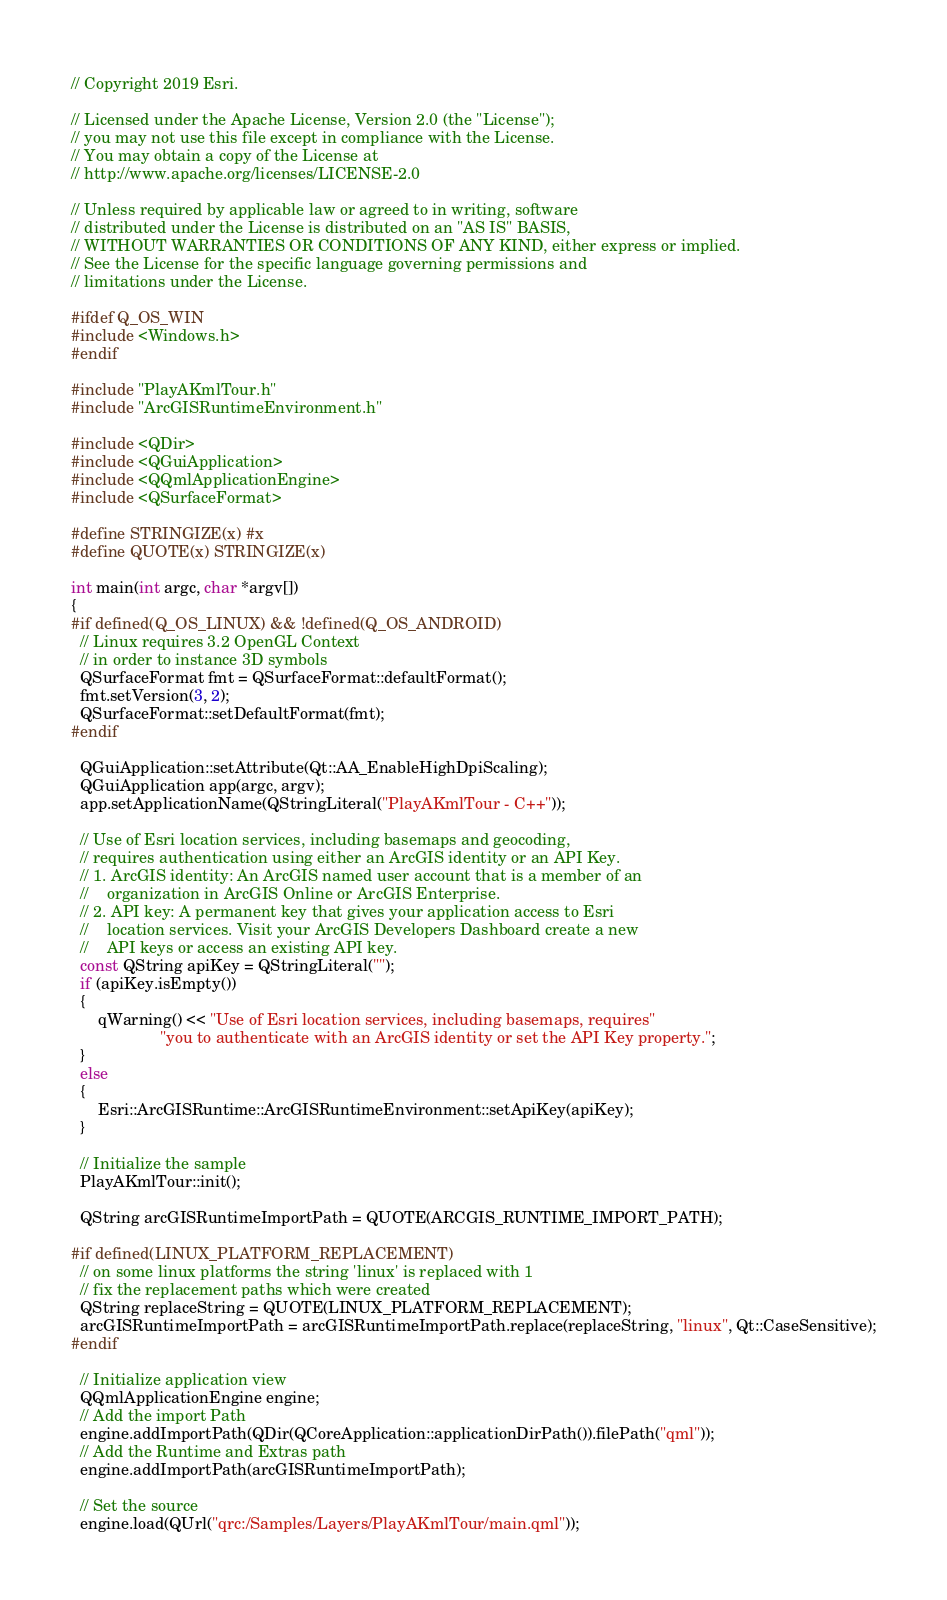Convert code to text. <code><loc_0><loc_0><loc_500><loc_500><_C++_>// Copyright 2019 Esri.

// Licensed under the Apache License, Version 2.0 (the "License");
// you may not use this file except in compliance with the License.
// You may obtain a copy of the License at
// http://www.apache.org/licenses/LICENSE-2.0

// Unless required by applicable law or agreed to in writing, software
// distributed under the License is distributed on an "AS IS" BASIS,
// WITHOUT WARRANTIES OR CONDITIONS OF ANY KIND, either express or implied.
// See the License for the specific language governing permissions and
// limitations under the License.

#ifdef Q_OS_WIN
#include <Windows.h>
#endif

#include "PlayAKmlTour.h"
#include "ArcGISRuntimeEnvironment.h"

#include <QDir>
#include <QGuiApplication>
#include <QQmlApplicationEngine>
#include <QSurfaceFormat>

#define STRINGIZE(x) #x
#define QUOTE(x) STRINGIZE(x)

int main(int argc, char *argv[])
{
#if defined(Q_OS_LINUX) && !defined(Q_OS_ANDROID)
  // Linux requires 3.2 OpenGL Context
  // in order to instance 3D symbols
  QSurfaceFormat fmt = QSurfaceFormat::defaultFormat();
  fmt.setVersion(3, 2);
  QSurfaceFormat::setDefaultFormat(fmt);
#endif

  QGuiApplication::setAttribute(Qt::AA_EnableHighDpiScaling);
  QGuiApplication app(argc, argv);
  app.setApplicationName(QStringLiteral("PlayAKmlTour - C++"));

  // Use of Esri location services, including basemaps and geocoding,
  // requires authentication using either an ArcGIS identity or an API Key.
  // 1. ArcGIS identity: An ArcGIS named user account that is a member of an
  //    organization in ArcGIS Online or ArcGIS Enterprise.
  // 2. API key: A permanent key that gives your application access to Esri
  //    location services. Visit your ArcGIS Developers Dashboard create a new
  //    API keys or access an existing API key.
  const QString apiKey = QStringLiteral("");
  if (apiKey.isEmpty())
  {
      qWarning() << "Use of Esri location services, including basemaps, requires"
                    "you to authenticate with an ArcGIS identity or set the API Key property.";
  }
  else
  {
      Esri::ArcGISRuntime::ArcGISRuntimeEnvironment::setApiKey(apiKey);
  }

  // Initialize the sample
  PlayAKmlTour::init();

  QString arcGISRuntimeImportPath = QUOTE(ARCGIS_RUNTIME_IMPORT_PATH);

#if defined(LINUX_PLATFORM_REPLACEMENT)
  // on some linux platforms the string 'linux' is replaced with 1
  // fix the replacement paths which were created
  QString replaceString = QUOTE(LINUX_PLATFORM_REPLACEMENT);
  arcGISRuntimeImportPath = arcGISRuntimeImportPath.replace(replaceString, "linux", Qt::CaseSensitive);
#endif

  // Initialize application view
  QQmlApplicationEngine engine;
  // Add the import Path
  engine.addImportPath(QDir(QCoreApplication::applicationDirPath()).filePath("qml"));
  // Add the Runtime and Extras path
  engine.addImportPath(arcGISRuntimeImportPath);

  // Set the source
  engine.load(QUrl("qrc:/Samples/Layers/PlayAKmlTour/main.qml"));
</code> 